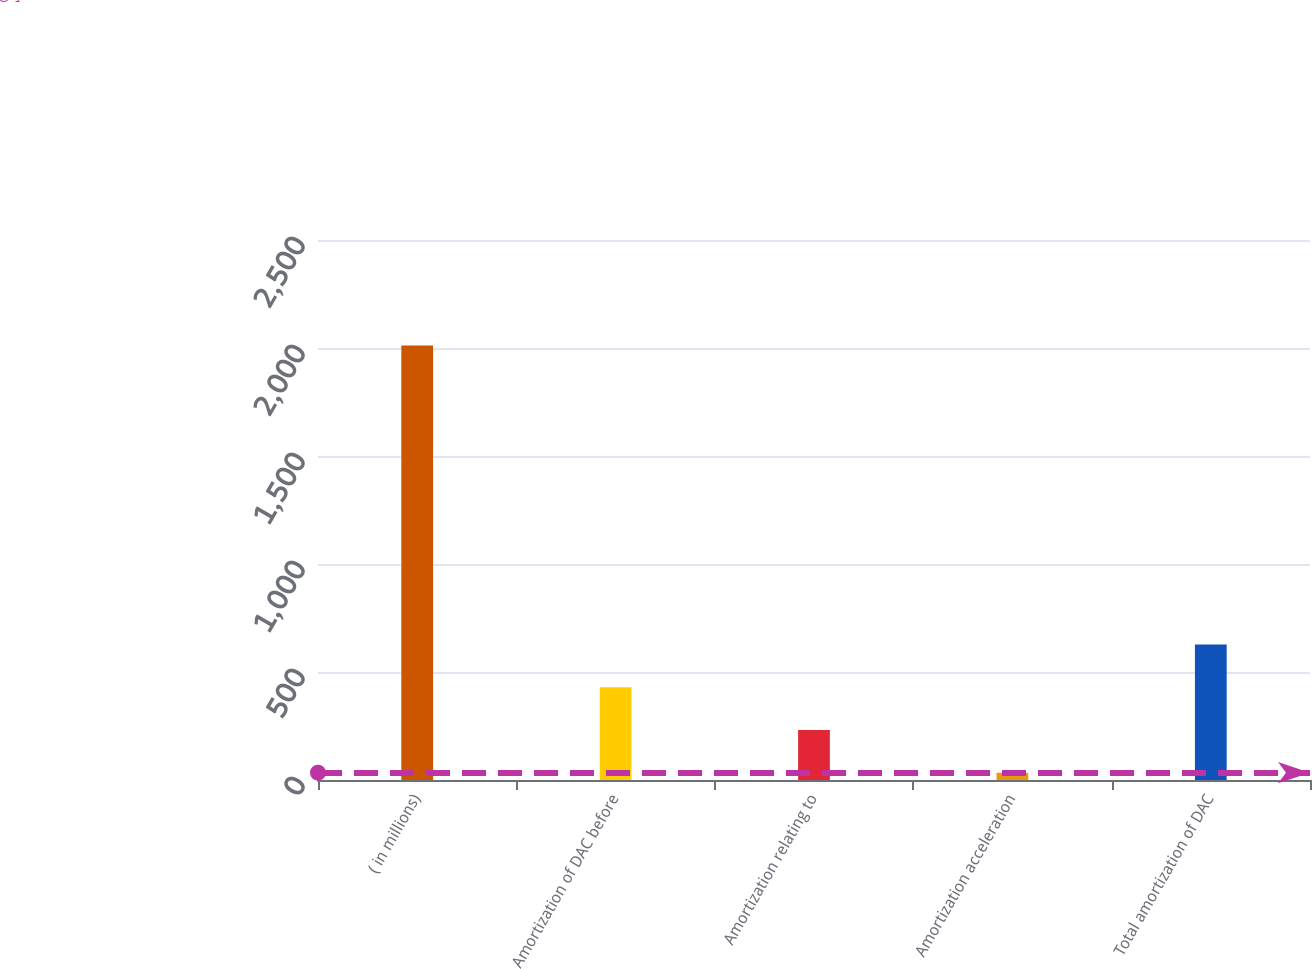<chart> <loc_0><loc_0><loc_500><loc_500><bar_chart><fcel>( in millions)<fcel>Amortization of DAC before<fcel>Amortization relating to<fcel>Amortization acceleration<fcel>Total amortization of DAC<nl><fcel>2012<fcel>429.6<fcel>231.8<fcel>34<fcel>627.4<nl></chart> 